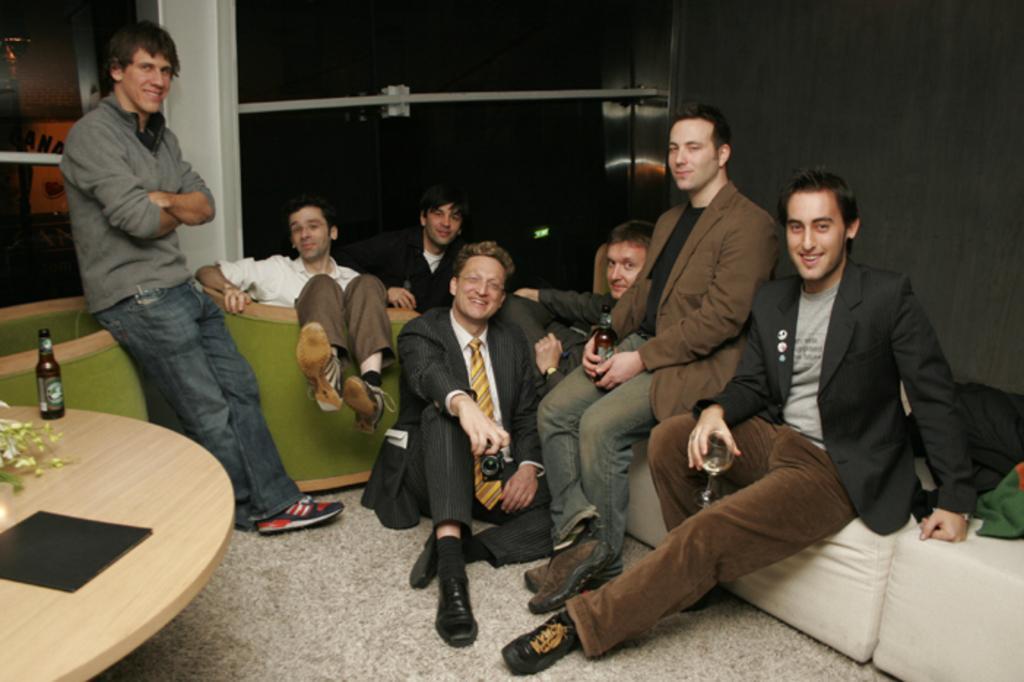Could you give a brief overview of what you see in this image? These persons sitting. This person standing. This is floor. There is table. On the table we can see bottle. On the background we can see window,wall. 